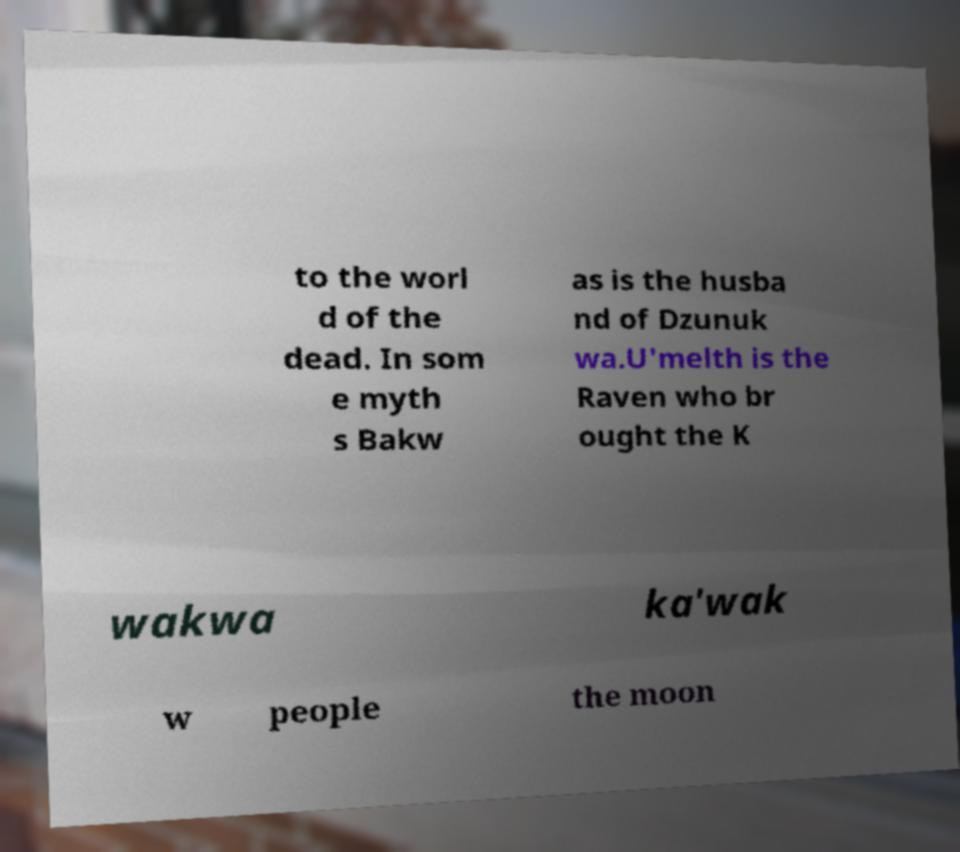Can you accurately transcribe the text from the provided image for me? to the worl d of the dead. In som e myth s Bakw as is the husba nd of Dzunuk wa.U'melth is the Raven who br ought the K wakwa ka'wak w people the moon 